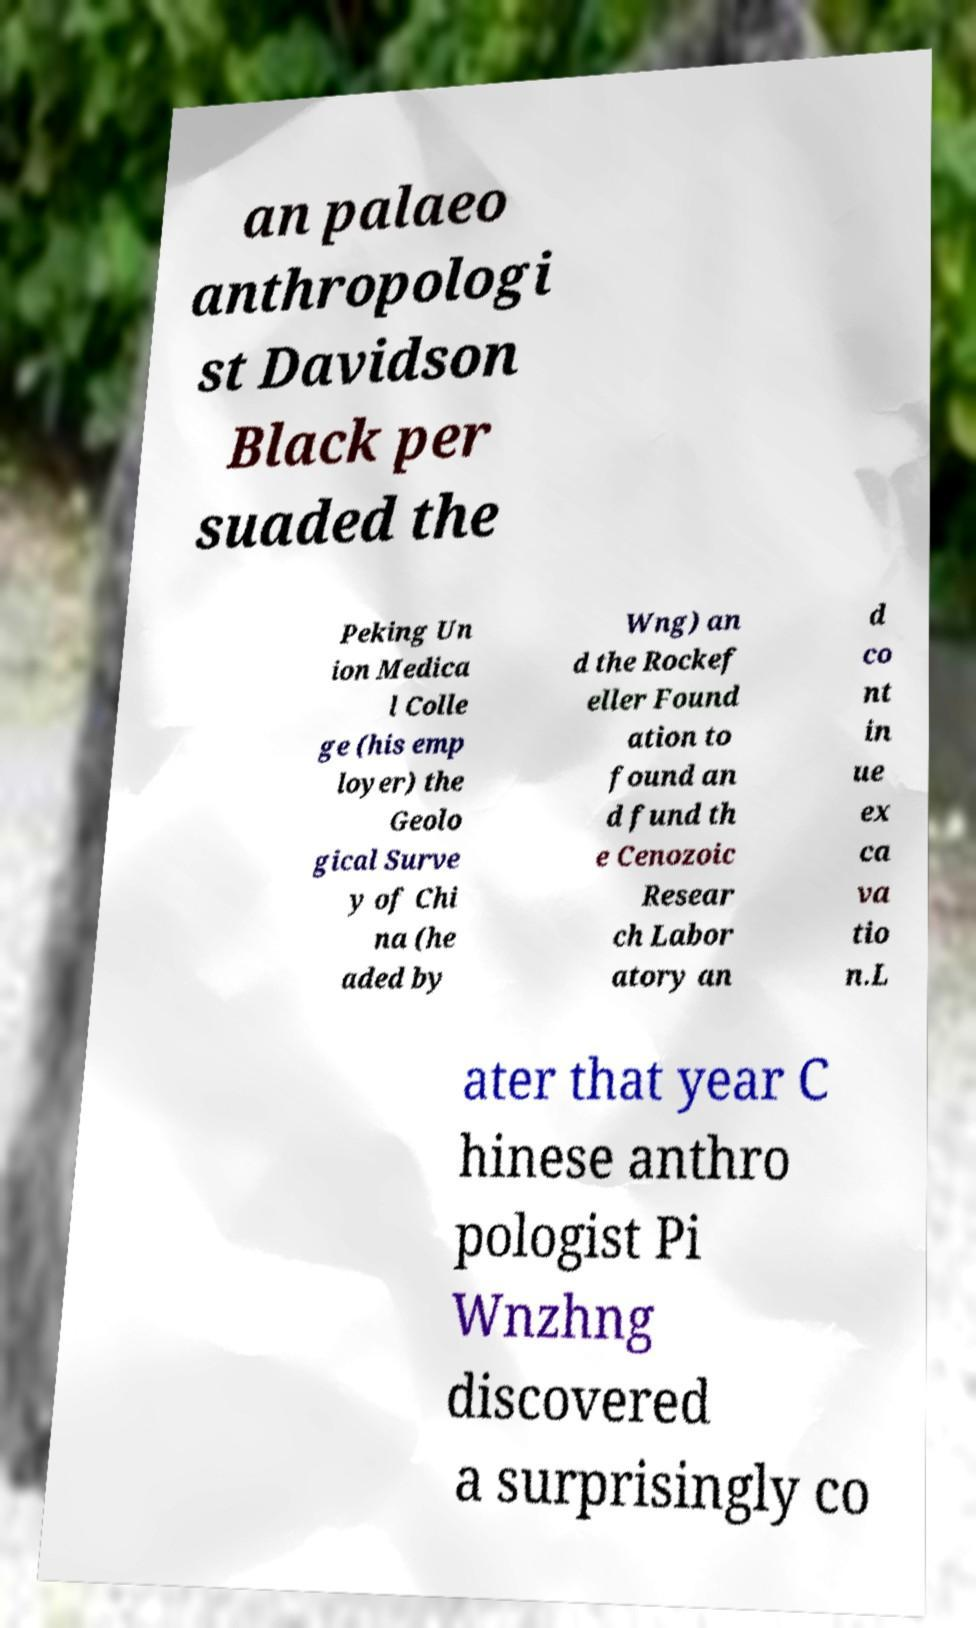Can you read and provide the text displayed in the image?This photo seems to have some interesting text. Can you extract and type it out for me? an palaeo anthropologi st Davidson Black per suaded the Peking Un ion Medica l Colle ge (his emp loyer) the Geolo gical Surve y of Chi na (he aded by Wng) an d the Rockef eller Found ation to found an d fund th e Cenozoic Resear ch Labor atory an d co nt in ue ex ca va tio n.L ater that year C hinese anthro pologist Pi Wnzhng discovered a surprisingly co 